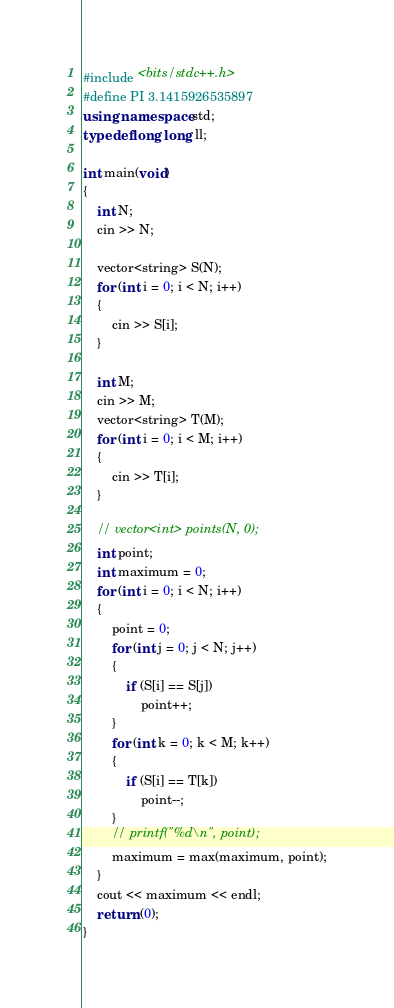Convert code to text. <code><loc_0><loc_0><loc_500><loc_500><_C++_>#include <bits/stdc++.h>
#define PI 3.1415926535897
using namespace std;
typedef long long ll;

int main(void)
{
    int N;
    cin >> N;

    vector<string> S(N);
    for (int i = 0; i < N; i++)
    {
        cin >> S[i];
    }

    int M;
    cin >> M;
    vector<string> T(M);
    for (int i = 0; i < M; i++)
    {
        cin >> T[i];
    }

    // vector<int> points(N, 0);
    int point;
    int maximum = 0;
    for (int i = 0; i < N; i++)
    {
        point = 0;
        for (int j = 0; j < N; j++)
        {
            if (S[i] == S[j])
                point++;
        }
        for (int k = 0; k < M; k++)
        {
            if (S[i] == T[k])
                point--;
        }
        // printf("%d\n", point);
        maximum = max(maximum, point);
    }
    cout << maximum << endl;
    return (0);
}</code> 